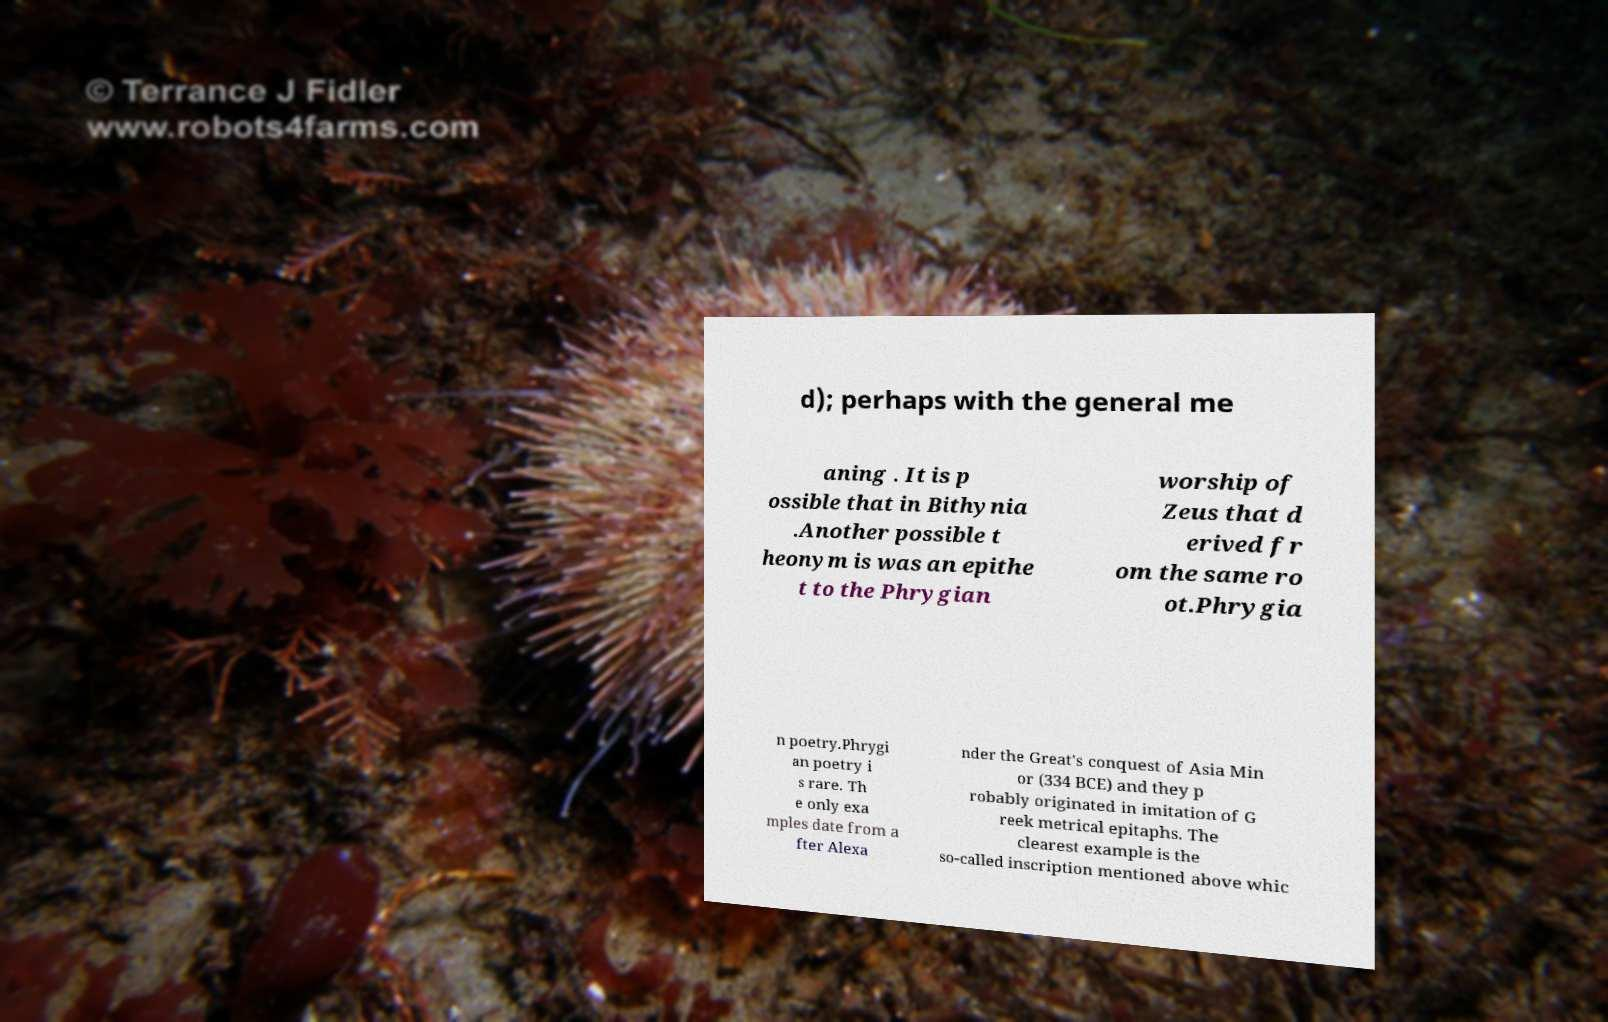Can you read and provide the text displayed in the image?This photo seems to have some interesting text. Can you extract and type it out for me? d); perhaps with the general me aning . It is p ossible that in Bithynia .Another possible t heonym is was an epithe t to the Phrygian worship of Zeus that d erived fr om the same ro ot.Phrygia n poetry.Phrygi an poetry i s rare. Th e only exa mples date from a fter Alexa nder the Great's conquest of Asia Min or (334 BCE) and they p robably originated in imitation of G reek metrical epitaphs. The clearest example is the so-called inscription mentioned above whic 